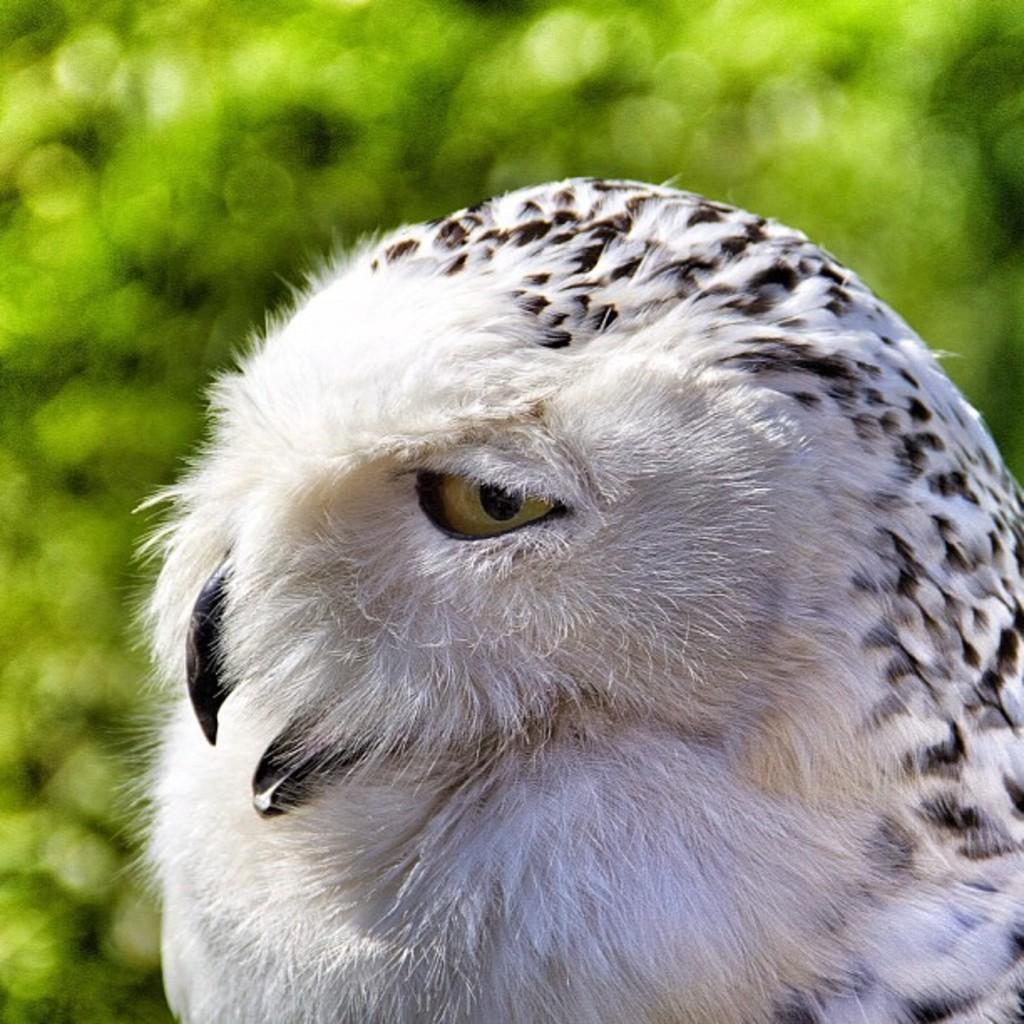In one or two sentences, can you explain what this image depicts? In the picture we can see some part of the bird owl with a fur and the black color beak and eye and on it we can see black color dots and behind the owl we can see which plants are not clearly visible. 